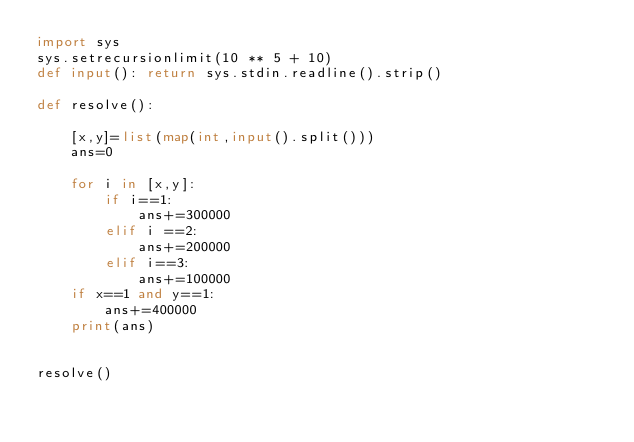<code> <loc_0><loc_0><loc_500><loc_500><_Python_>import sys
sys.setrecursionlimit(10 ** 5 + 10)
def input(): return sys.stdin.readline().strip()

def resolve():

    [x,y]=list(map(int,input().split()))
    ans=0

    for i in [x,y]:
        if i==1:
            ans+=300000
        elif i ==2:
            ans+=200000
        elif i==3:
            ans+=100000
    if x==1 and y==1:
        ans+=400000
    print(ans)


resolve()</code> 